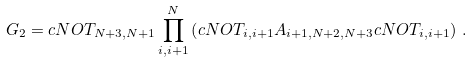<formula> <loc_0><loc_0><loc_500><loc_500>G _ { 2 } = c N O T _ { N + 3 , N + 1 } \prod _ { i , i + 1 } ^ { N } \left ( c N O T _ { i , i + 1 } A _ { i + 1 , N + 2 , N + 3 } c N O T _ { i , i + 1 } \right ) \, .</formula> 